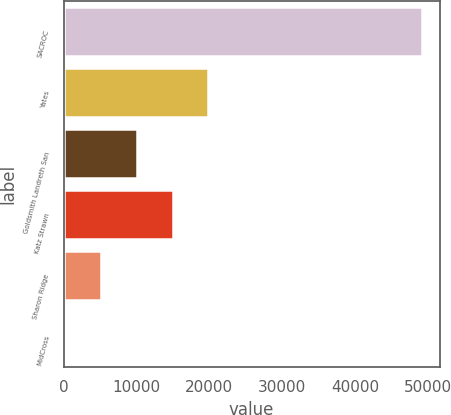Convert chart to OTSL. <chart><loc_0><loc_0><loc_500><loc_500><bar_chart><fcel>SACROC<fcel>Yates<fcel>Goldsmith Landreth San<fcel>Katz Strawn<fcel>Sharon Ridge<fcel>MidCross<nl><fcel>49156<fcel>19854.4<fcel>10087.2<fcel>14970.8<fcel>5203.6<fcel>320<nl></chart> 